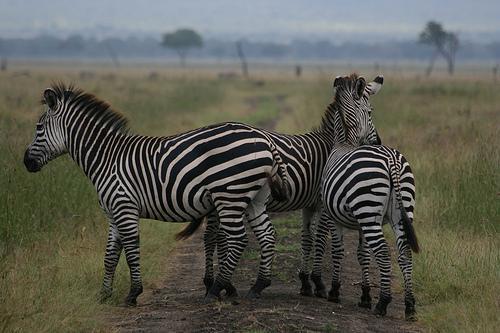How many zebras are there?
Give a very brief answer. 3. How many legs are there?
Give a very brief answer. 12. How many zebra heads are visible?
Give a very brief answer. 2. 